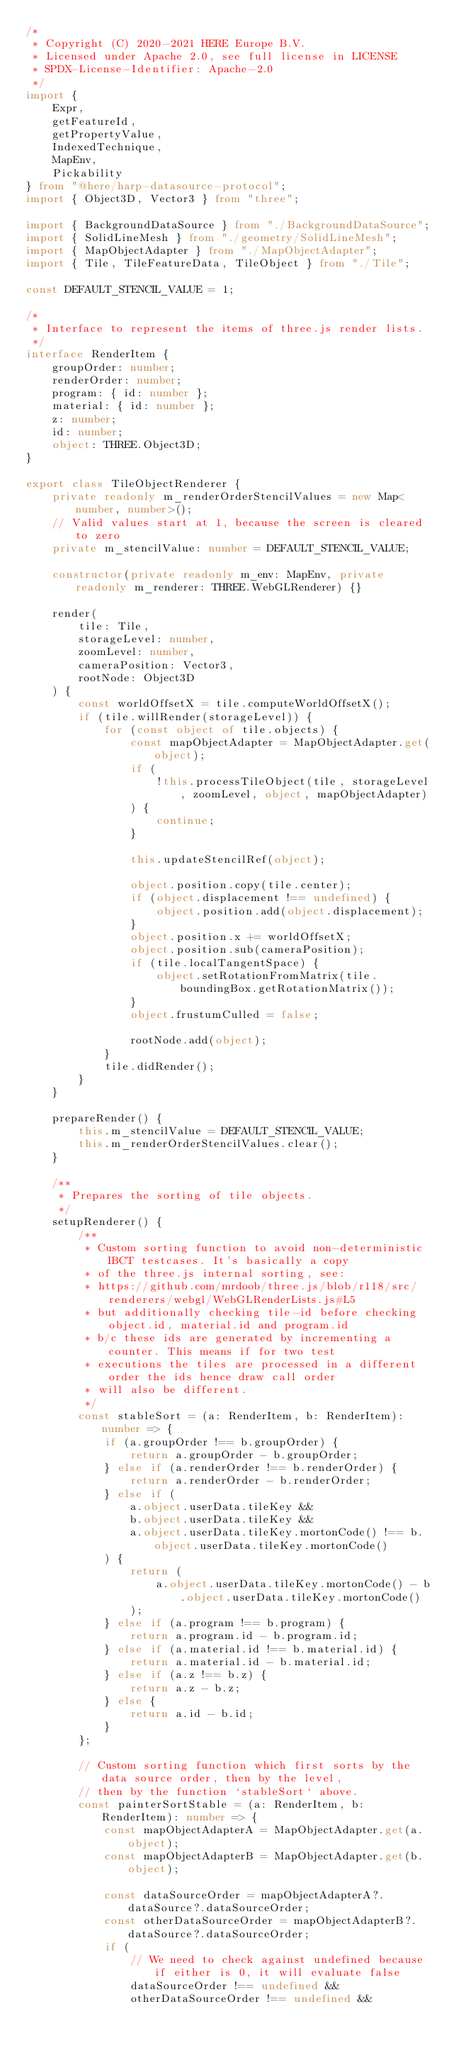<code> <loc_0><loc_0><loc_500><loc_500><_TypeScript_>/*
 * Copyright (C) 2020-2021 HERE Europe B.V.
 * Licensed under Apache 2.0, see full license in LICENSE
 * SPDX-License-Identifier: Apache-2.0
 */
import {
    Expr,
    getFeatureId,
    getPropertyValue,
    IndexedTechnique,
    MapEnv,
    Pickability
} from "@here/harp-datasource-protocol";
import { Object3D, Vector3 } from "three";

import { BackgroundDataSource } from "./BackgroundDataSource";
import { SolidLineMesh } from "./geometry/SolidLineMesh";
import { MapObjectAdapter } from "./MapObjectAdapter";
import { Tile, TileFeatureData, TileObject } from "./Tile";

const DEFAULT_STENCIL_VALUE = 1;

/*
 * Interface to represent the items of three.js render lists.
 */
interface RenderItem {
    groupOrder: number;
    renderOrder: number;
    program: { id: number };
    material: { id: number };
    z: number;
    id: number;
    object: THREE.Object3D;
}

export class TileObjectRenderer {
    private readonly m_renderOrderStencilValues = new Map<number, number>();
    // Valid values start at 1, because the screen is cleared to zero
    private m_stencilValue: number = DEFAULT_STENCIL_VALUE;

    constructor(private readonly m_env: MapEnv, private readonly m_renderer: THREE.WebGLRenderer) {}

    render(
        tile: Tile,
        storageLevel: number,
        zoomLevel: number,
        cameraPosition: Vector3,
        rootNode: Object3D
    ) {
        const worldOffsetX = tile.computeWorldOffsetX();
        if (tile.willRender(storageLevel)) {
            for (const object of tile.objects) {
                const mapObjectAdapter = MapObjectAdapter.get(object);
                if (
                    !this.processTileObject(tile, storageLevel, zoomLevel, object, mapObjectAdapter)
                ) {
                    continue;
                }

                this.updateStencilRef(object);

                object.position.copy(tile.center);
                if (object.displacement !== undefined) {
                    object.position.add(object.displacement);
                }
                object.position.x += worldOffsetX;
                object.position.sub(cameraPosition);
                if (tile.localTangentSpace) {
                    object.setRotationFromMatrix(tile.boundingBox.getRotationMatrix());
                }
                object.frustumCulled = false;

                rootNode.add(object);
            }
            tile.didRender();
        }
    }

    prepareRender() {
        this.m_stencilValue = DEFAULT_STENCIL_VALUE;
        this.m_renderOrderStencilValues.clear();
    }

    /**
     * Prepares the sorting of tile objects.
     */
    setupRenderer() {
        /**
         * Custom sorting function to avoid non-deterministic IBCT testcases. It's basically a copy
         * of the three.js internal sorting, see:
         * https://github.com/mrdoob/three.js/blob/r118/src/renderers/webgl/WebGLRenderLists.js#L5
         * but additionally checking tile-id before checking object.id, material.id and program.id
         * b/c these ids are generated by incrementing a counter. This means if for two test
         * executions the tiles are processed in a different order the ids hence draw call order
         * will also be different.
         */
        const stableSort = (a: RenderItem, b: RenderItem): number => {
            if (a.groupOrder !== b.groupOrder) {
                return a.groupOrder - b.groupOrder;
            } else if (a.renderOrder !== b.renderOrder) {
                return a.renderOrder - b.renderOrder;
            } else if (
                a.object.userData.tileKey &&
                b.object.userData.tileKey &&
                a.object.userData.tileKey.mortonCode() !== b.object.userData.tileKey.mortonCode()
            ) {
                return (
                    a.object.userData.tileKey.mortonCode() - b.object.userData.tileKey.mortonCode()
                );
            } else if (a.program !== b.program) {
                return a.program.id - b.program.id;
            } else if (a.material.id !== b.material.id) {
                return a.material.id - b.material.id;
            } else if (a.z !== b.z) {
                return a.z - b.z;
            } else {
                return a.id - b.id;
            }
        };

        // Custom sorting function which first sorts by the data source order, then by the level,
        // then by the function `stableSort` above.
        const painterSortStable = (a: RenderItem, b: RenderItem): number => {
            const mapObjectAdapterA = MapObjectAdapter.get(a.object);
            const mapObjectAdapterB = MapObjectAdapter.get(b.object);

            const dataSourceOrder = mapObjectAdapterA?.dataSource?.dataSourceOrder;
            const otherDataSourceOrder = mapObjectAdapterB?.dataSource?.dataSourceOrder;
            if (
                // We need to check against undefined because if either is 0, it will evaluate false
                dataSourceOrder !== undefined &&
                otherDataSourceOrder !== undefined &&</code> 